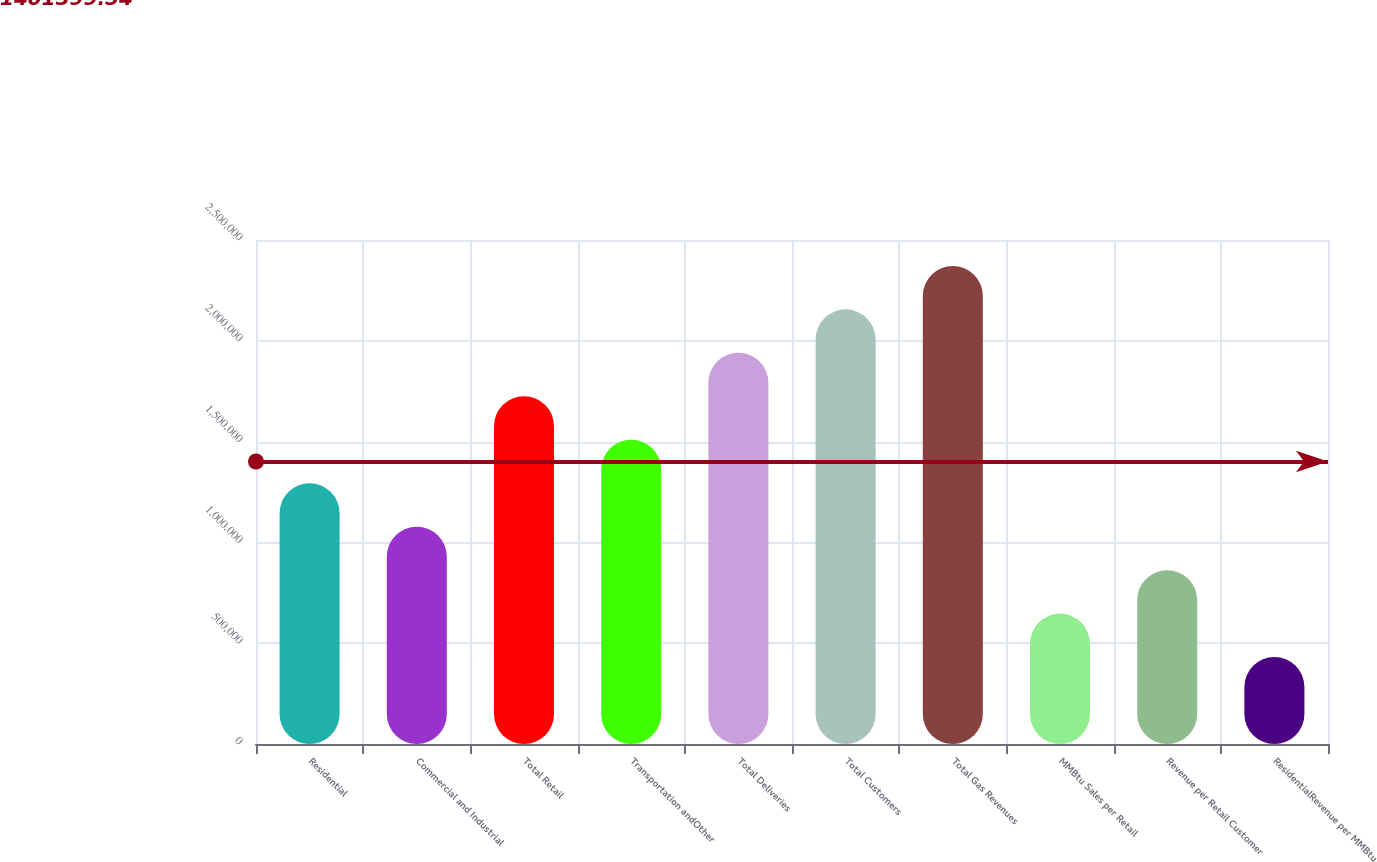Convert chart. <chart><loc_0><loc_0><loc_500><loc_500><bar_chart><fcel>Residential<fcel>Commercial and Industrial<fcel>Total Retail<fcel>Transportation andOther<fcel>Total Deliveries<fcel>Total Customers<fcel>Total Gas Revenues<fcel>MMBtu Sales per Retail<fcel>Revenue per Retail Customer<fcel>ResidentialRevenue per MMBtu<nl><fcel>1.2936e+06<fcel>1.078e+06<fcel>1.7248e+06<fcel>1.5092e+06<fcel>1.9404e+06<fcel>2.156e+06<fcel>2.3716e+06<fcel>646800<fcel>862400<fcel>431200<nl></chart> 